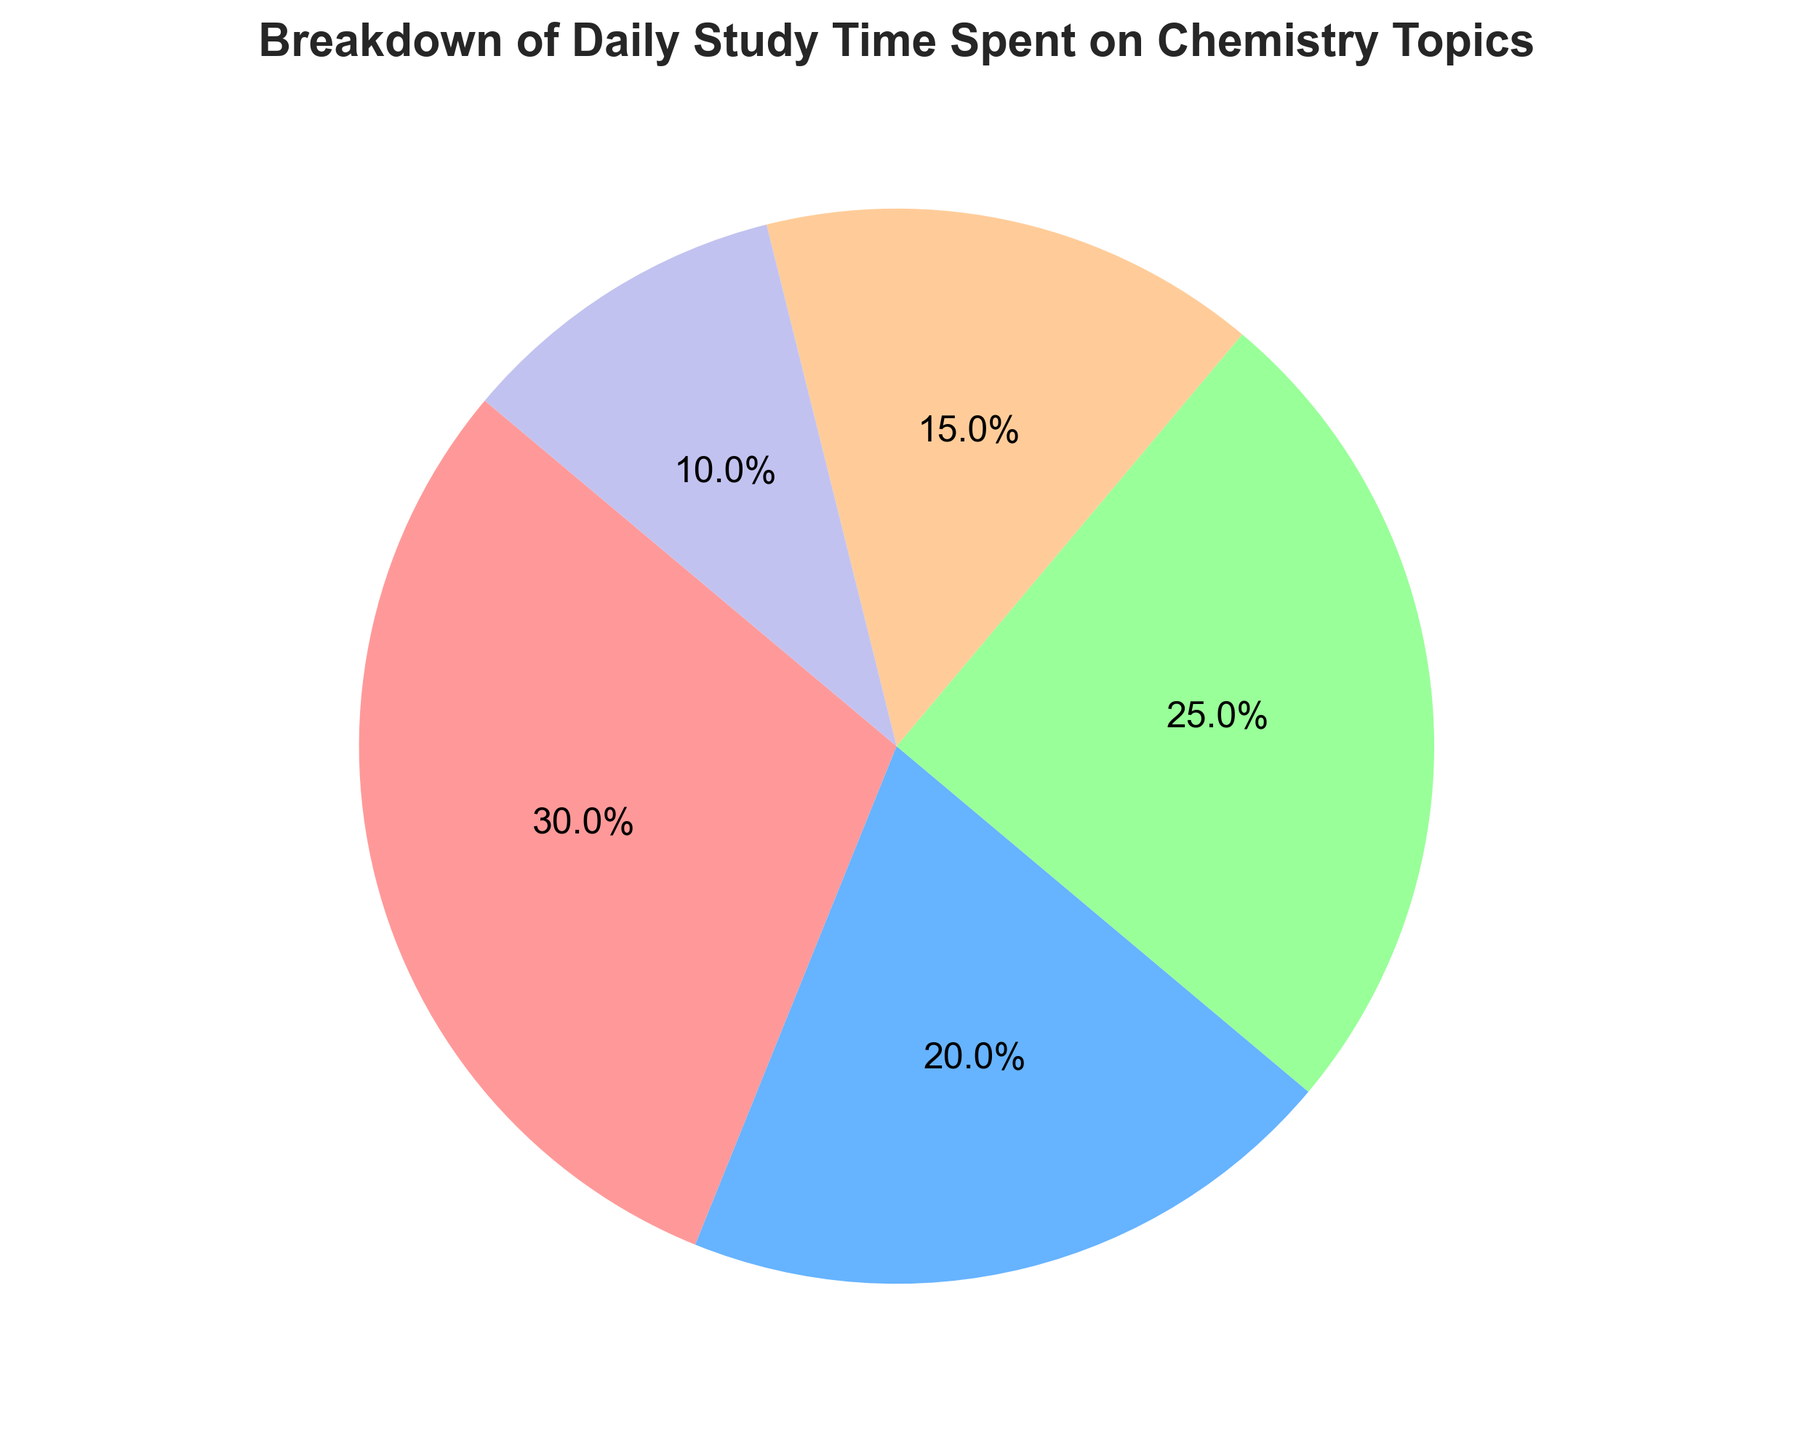What's the total daily study time spent on all Chemistry topics? Add the time spent on each chemistry topic: 90 (Organic) + 60 (Inorganic) + 75 (Physical) + 45 (Analytical) + 30 (Biochemistry) minutes. Therefore, the total study time is 300 minutes.
Answer: 300 minutes Which chemistry topic takes up the largest proportion of study time? Identify the segment with the largest percentage in the pie chart, which is often visually the largest segment. Here, Organic Chemistry is the largest and has 30.0%.
Answer: Organic Chemistry How much more time is spent on Organic Chemistry compared to Biochemistry? Subtract the time spent on Biochemistry from the time spent on Organic Chemistry: 90 - 30 = 60 minutes.
Answer: 60 minutes Which two chemistry topics combined take up the least time? Identify the two smallest segments in the pie chart. The smallest segments are Biochemistry (30 minutes) and Analytical Chemistry (45 minutes). Together, they take up 30 + 45 = 75 minutes.
Answer: Biochemistry and Analytical Chemistry What percentage of the daily study time is spent on Physical Chemistry? The time spent on Physical Chemistry is 75 minutes out of the total 300 minutes. The percentage is computed as (75/300) * 100 = 25%.
Answer: 25% Is more time spent on Inorganic Chemistry or Analytical Chemistry? Compare the time spent on both topics. Inorganic Chemistry has 60 minutes, while Analytical Chemistry has 45 minutes. Thus, more time is spent on Inorganic Chemistry.
Answer: Inorganic Chemistry How many minutes less are spent on Biochemistry than on Physical Chemistry? Subtract the time spent on Biochemistry from the time spent on Physical Chemistry: 75 - 30 = 45 minutes.
Answer: 45 minutes If the total study time is increased by 1 hour, what will be the new time spent on Organic Chemistry if the proportion remains the same? First, increase the total time by 60 minutes: 300 + 60 = 360 minutes. Organic Chemistry makes up 30% of the total time. Thus, the new time is 30% of 360 minutes which is 360 * 0.30 = 108 minutes.
Answer: 108 minutes What is the ratio of the time spent on Inorganic Chemistry to the time spent on Analytical Chemistry? The time spent on Inorganic Chemistry is 60 minutes, and the time spent on Analytical Chemistry is 45 minutes. The ratio is 60:45, which can be simplified by dividing both numbers by their greatest common divisor, 15. The simplified ratio is 4:3.
Answer: 4:3 Which topics have time allocations that are approximately the same (within 15 minutes)? Compare the time spent on each topic to see which pairs have a difference of 15 minutes or less. Physical Chemistry (75 minutes) and Inorganic Chemistry (60 minutes) have a difference of 15 minutes, and Inorganic Chemistry (60 minutes) and Organic Chemistry (90 minutes) have a difference of 30 minutes, which is not within 15 minutes. So only Physical and Inorganic Chemistry are approximately the same.
Answer: Physical Chemistry and Inorganic Chemistry 